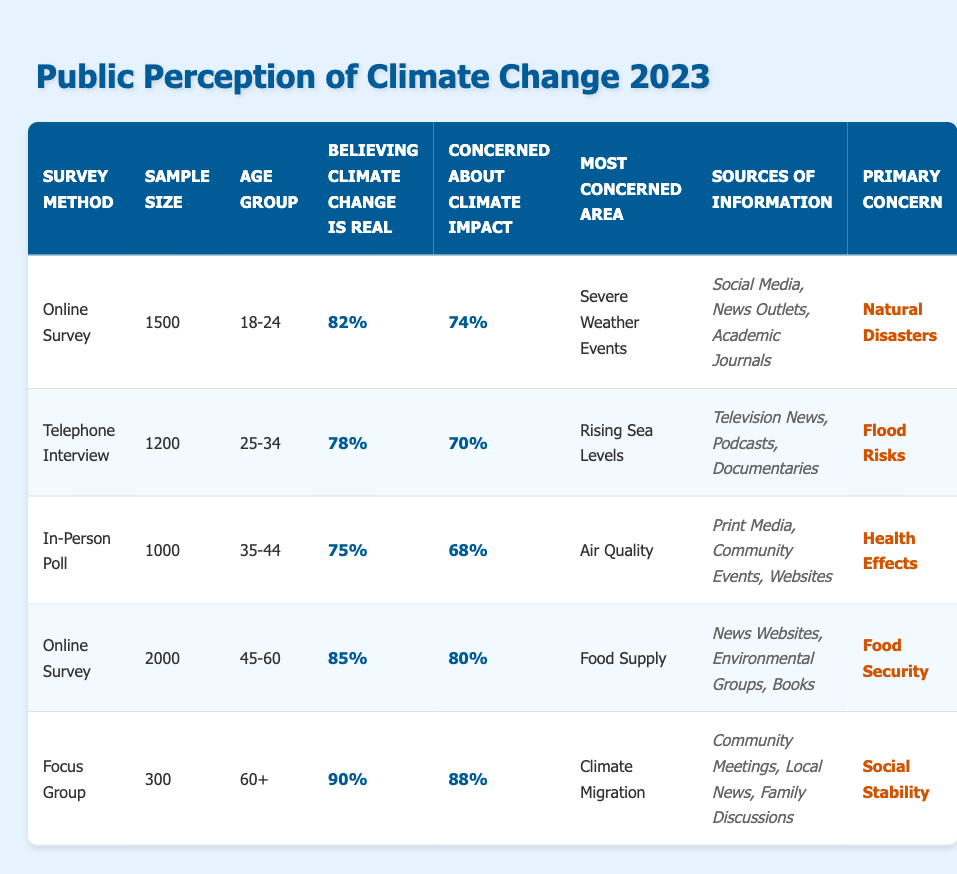What percentage of the 45-60 age group believes climate change is real? Referring to the table under the "Demographic Age Group" column for 45-60, the "Percentage Believing Climate Change Is Real" shows 85%.
Answer: 85% What is the primary concern for the 18-24 age group? Looking at the "Primary Concern" column for the 18-24 age group, it states Natural Disasters.
Answer: Natural Disasters What are the sources of information for the 60+ age group? Checking the "Sources of Information" column for the 60+ age group, it lists Community Meetings, Local News, and Family Discussions.
Answer: Community Meetings, Local News, Family Discussions Which age group has the highest percentage of individuals concerned about climate impact? For the age groups, the percentages concerned about climate impact are 74% (18-24), 70% (25-34), 68% (35-44), 80% (45-60), and 88% (60+). The highest is 88% for the 60+ age group.
Answer: 60+ What is the average percentage of people believing climate change is real across all age groups? The percentages are 82% (18-24), 78% (25-34), 75% (35-44), 85% (45-60), and 90% (60+). Summing these gives 410%, and dividing by 5 (the number of groups) results in an average of 82%.
Answer: 82% Is the most concerned area for the 25-34 age group related to severe weather events? The most concerned area for the 25-34 age group is Rising Sea Levels, which is not related to severe weather events.
Answer: No What is the percentage of individuals aged 35-44 who are concerned about climate impact? The percentage concerned about climate impact for the 35-44 age group is 68%, as indicated in the table under that group's row.
Answer: 68% For which demographic group is Food Security the primary concern? In the table, Food Security is listed as the primary concern for the 45-60 age group.
Answer: 45-60 age group What percentage of the 60+ age group believes climate change is real, and how does it compare to the 18-24 age group's percentage? The 60+ age group has 90% believing climate change is real, while the 18-24 group has 82%. The difference is 8% higher in the 60+ group.
Answer: 90%, 8% higher 